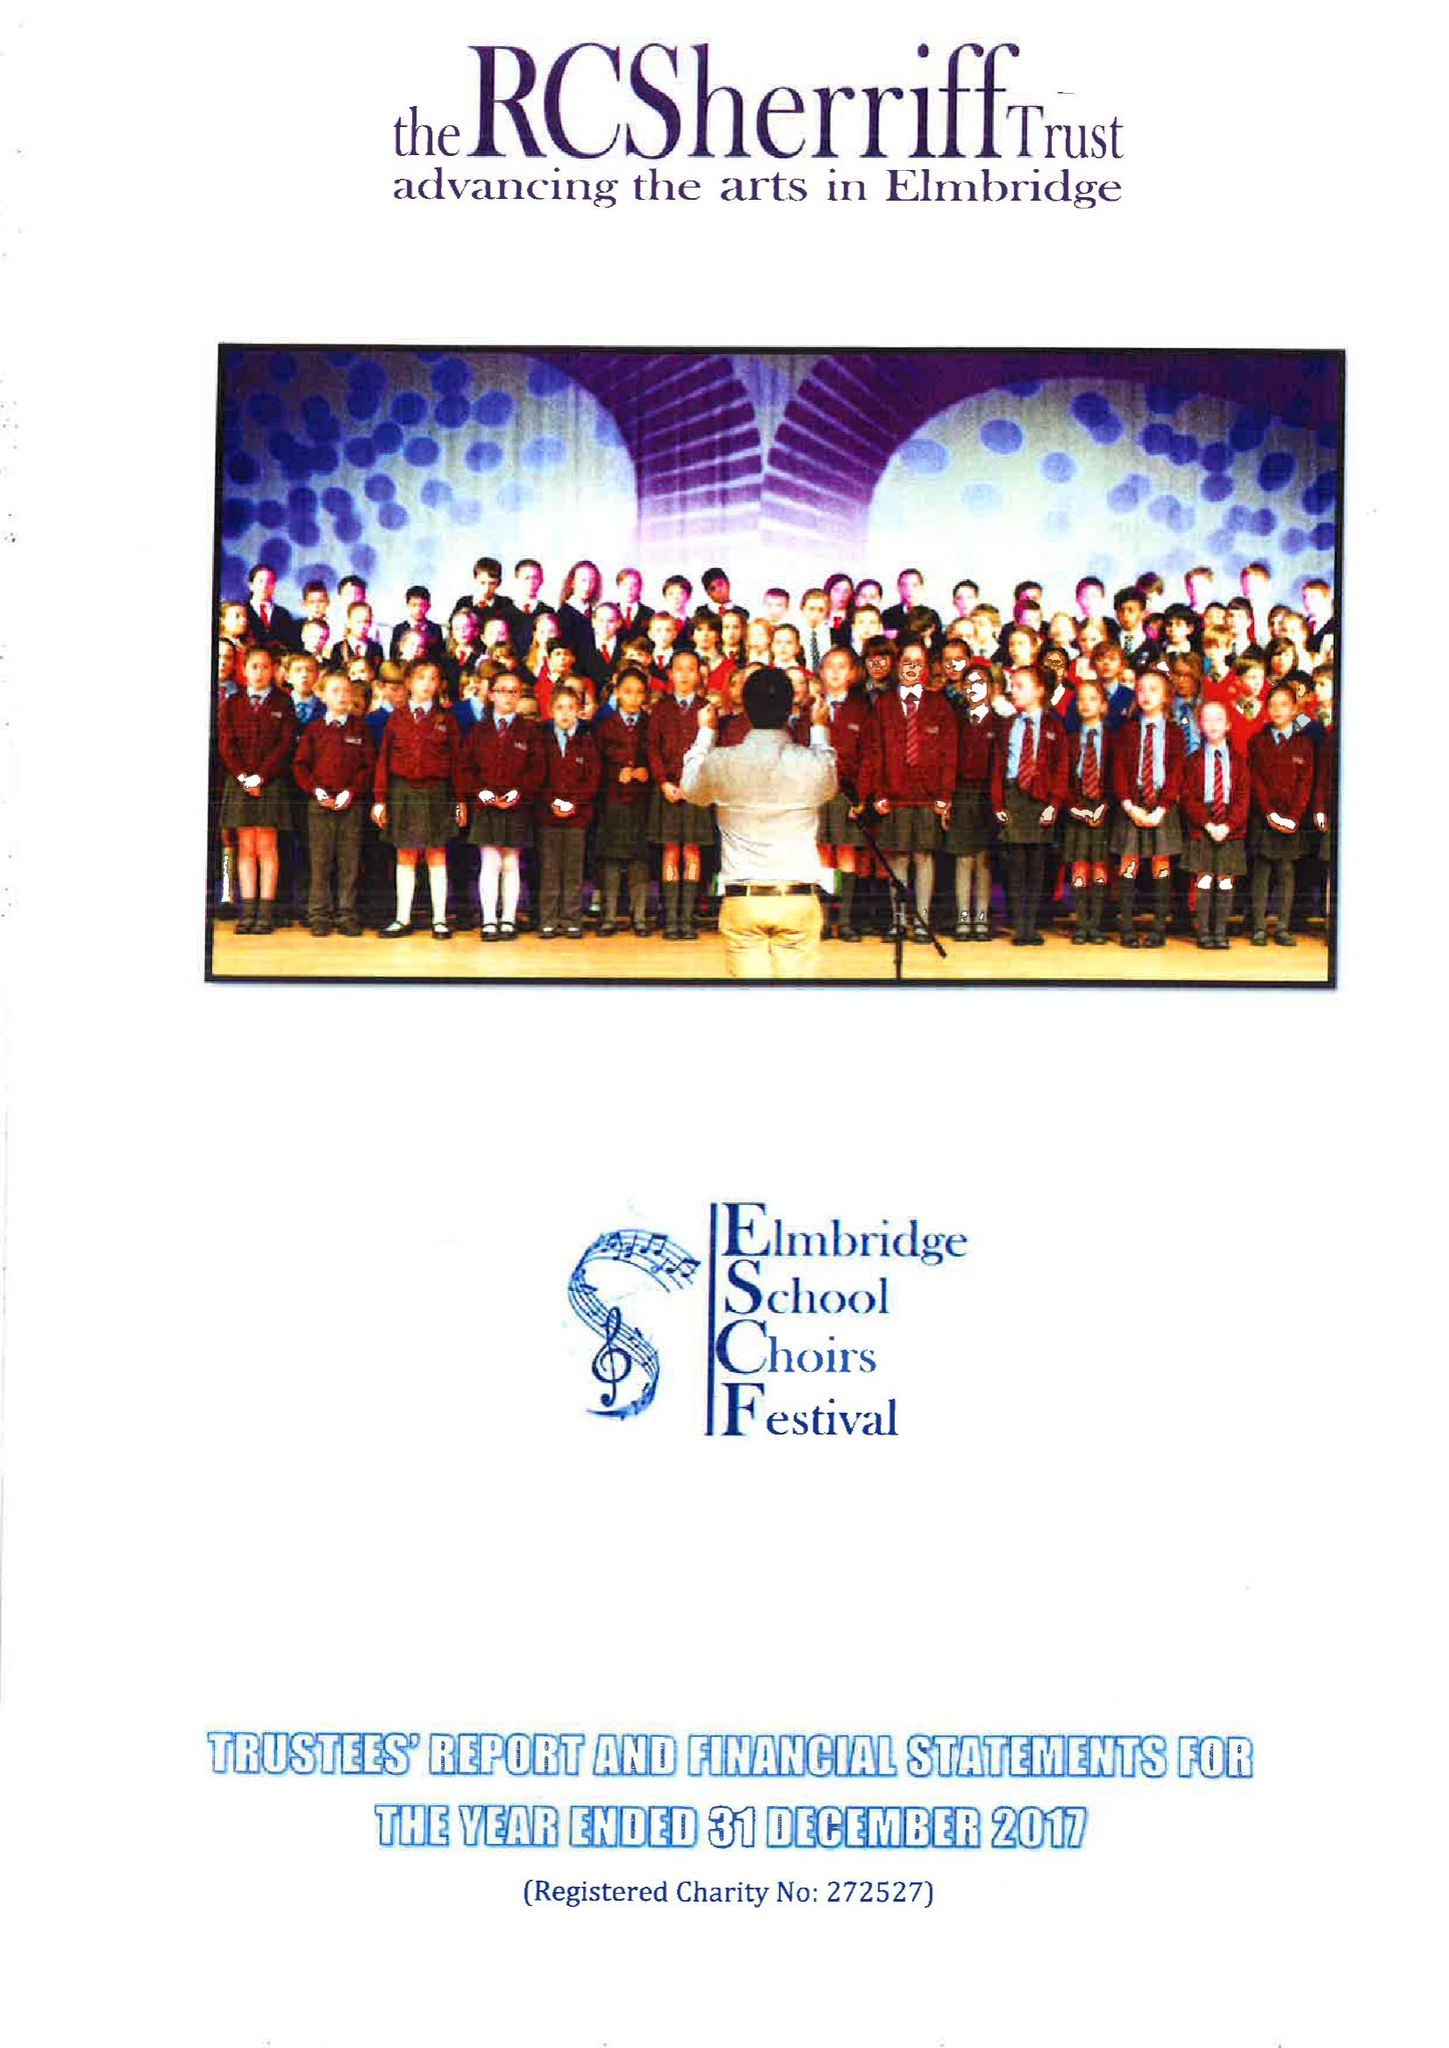What is the value for the report_date?
Answer the question using a single word or phrase. 2017-12-31 